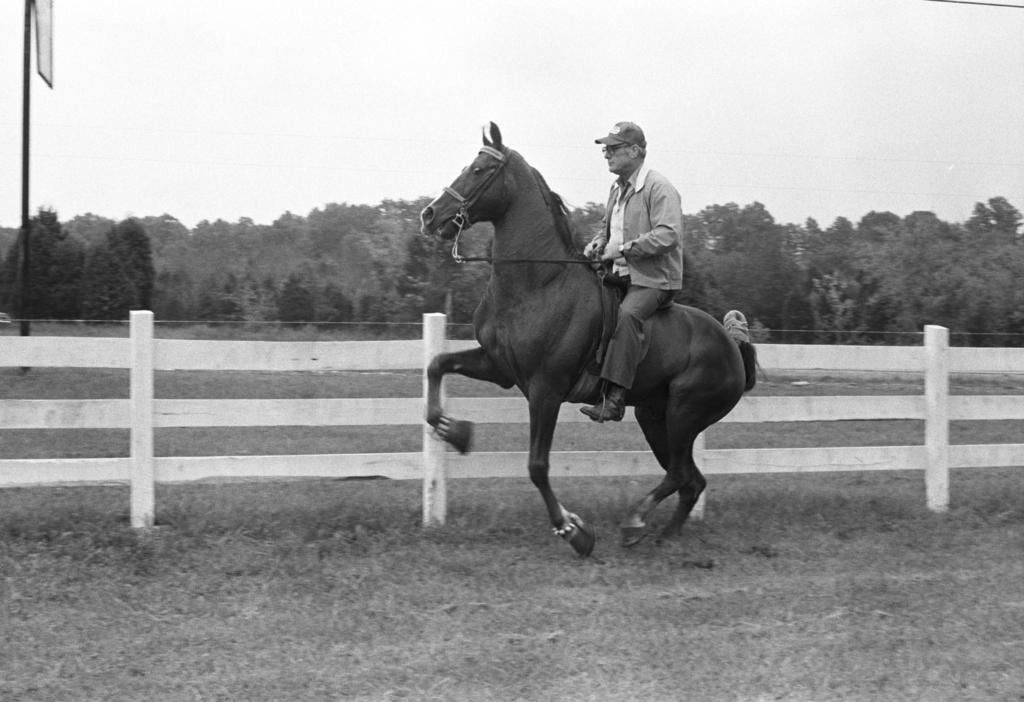What is the color scheme of the image? The image is black and white. What is the person in the image doing? The person is sitting on a horse. What type of headwear is the person wearing? The person is wearing a cap. What can be seen in the distance in the image? There are trees in the distance. What structure is present in the image? There is a board with a pole in the image. What architectural feature is near a house in the image? There is a fence near a house in the image. How many team members are visible in the image? There is no team or team members present in the image; it features a person sitting on a horse. What type of stick is the passenger holding in the image? There is no passenger or stick present in the image; it features a person sitting on a horse. 